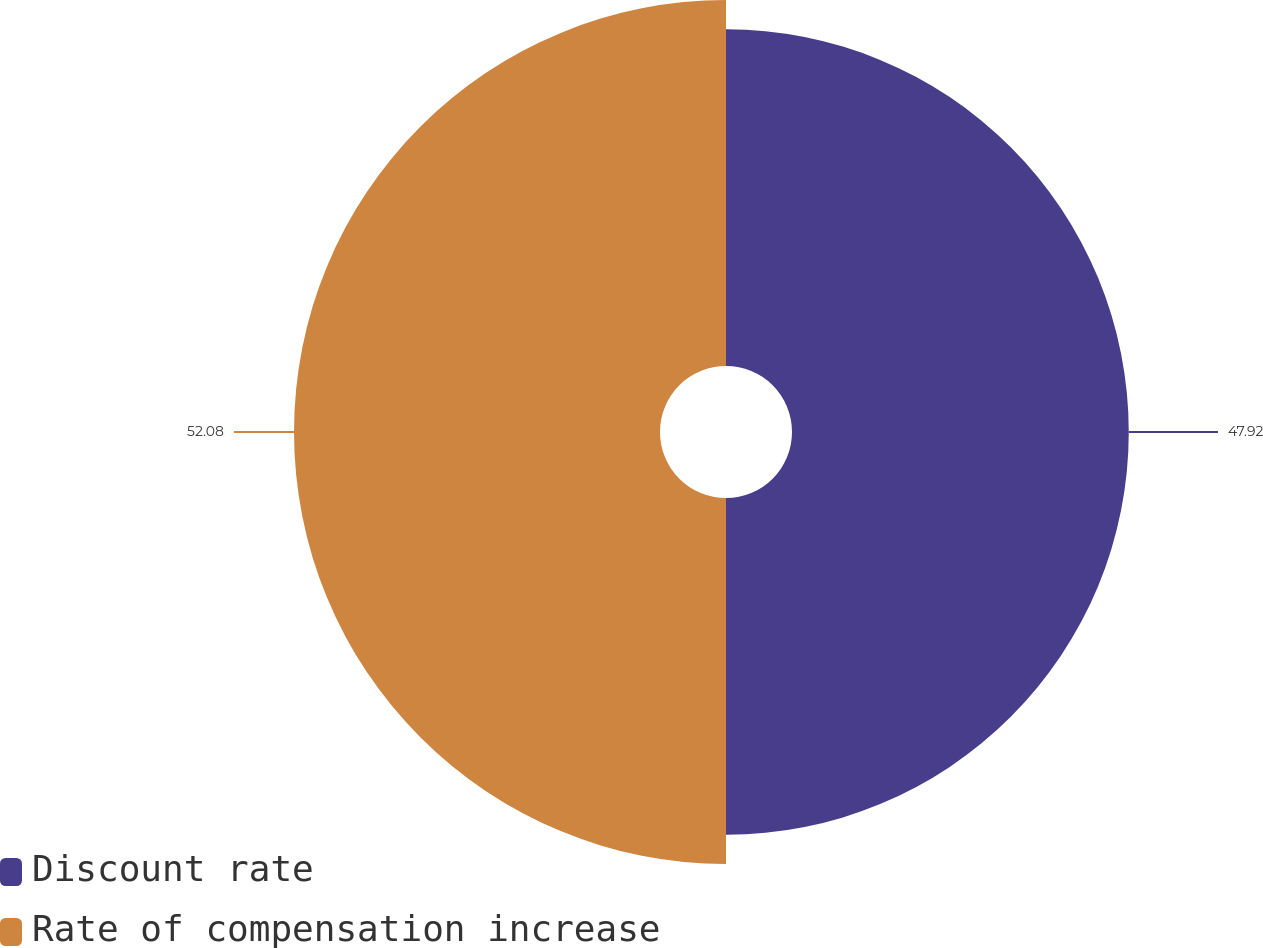Convert chart to OTSL. <chart><loc_0><loc_0><loc_500><loc_500><pie_chart><fcel>Discount rate<fcel>Rate of compensation increase<nl><fcel>47.92%<fcel>52.08%<nl></chart> 